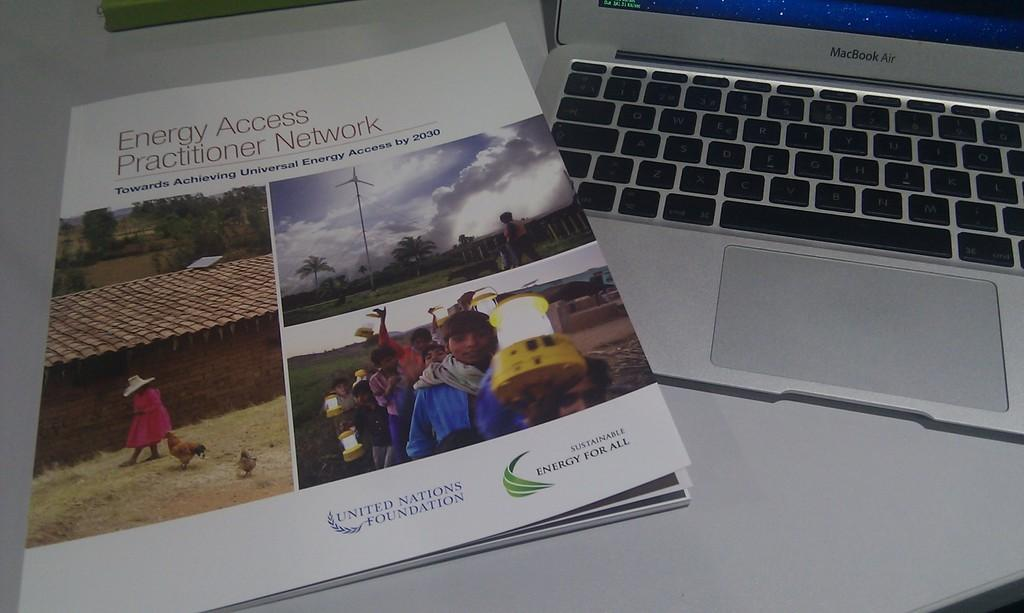<image>
Summarize the visual content of the image. An Energy Access Practioner Network book is next to a MacBook air laptop. 